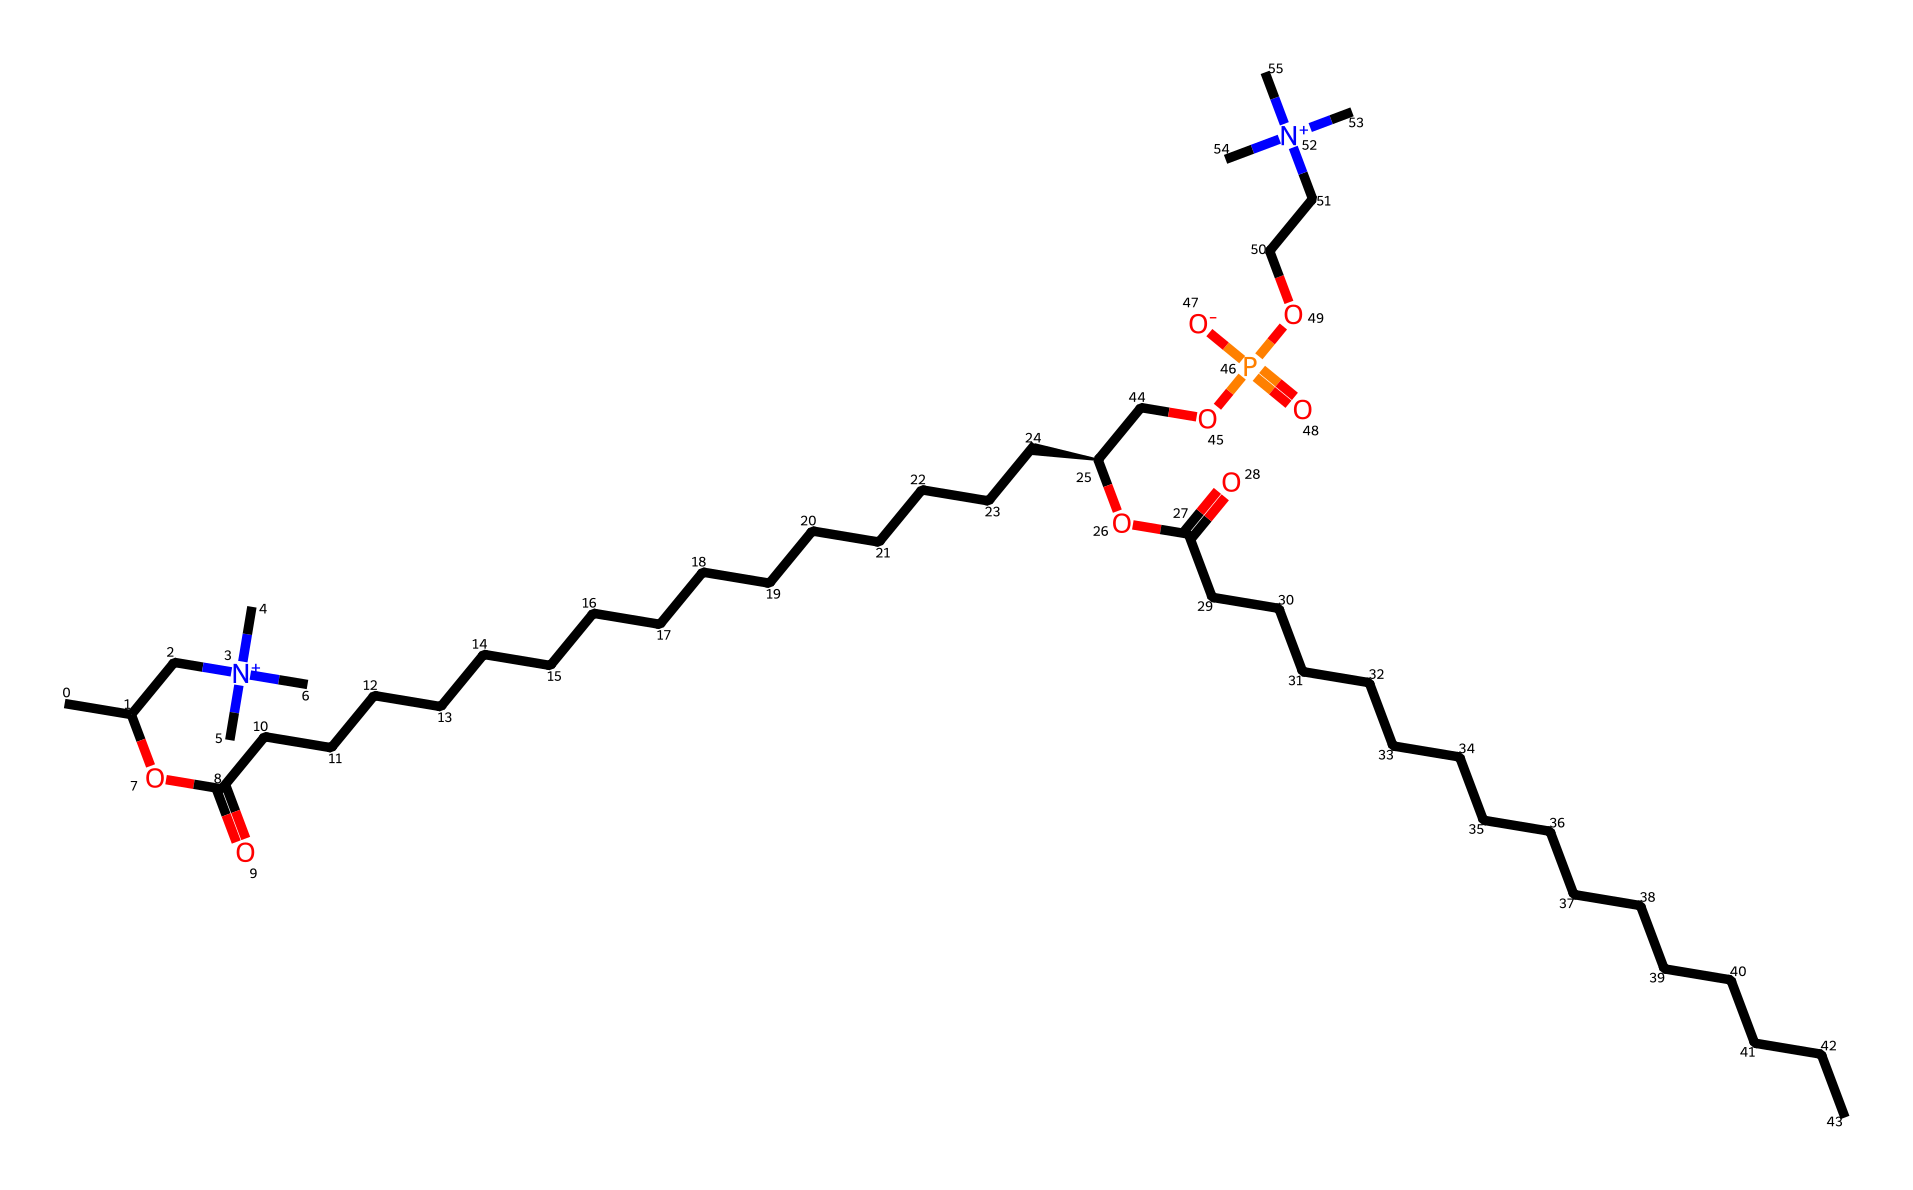What is the total number of carbon atoms in this compound? By inspecting the SMILES, we can count the carbon (C) symbols. There are 21 carbon atoms in total indicated in various parts of the structure.
Answer: 21 How many nitrogen atoms are present in the chemical structure? We can identify nitrogen (N) symbols in the SMILES. There are 4 nitrogen atoms present in the structure.
Answer: 4 What is the main functional group associated with this molecule? The functional group present in this compound is the phosphocholine group, which contains a phosphorus atom bonded to oxygen and nitrogen, indicating its role as a phospholipid.
Answer: phosphocholine What is the significance of the phosphate group in this compound? The phosphate group contributes to the hydrophilic nature of the molecule, allowing it to interact with water, which is essential for forming biological membranes.
Answer: hydrophilic How many ester linkages are observed in the structure? By analyzing the SMILES, we can find ester linkages present between the glycerol backbone and fatty acid chains. There are 2 ester linkages in this molecule.
Answer: 2 What role does this chemical play in biological systems? This molecule serves as a major component of cell membranes, providing structural integrity and functionality crucial for cell signaling and membrane dynamics.
Answer: membrane component What is the charge on the nitrogen atoms in this compound? The SMILES indicates that the nitrogen atoms are positively charged, as denoted by the [N+] notation, typically involved in forming zwitterionic forms.
Answer: positive 